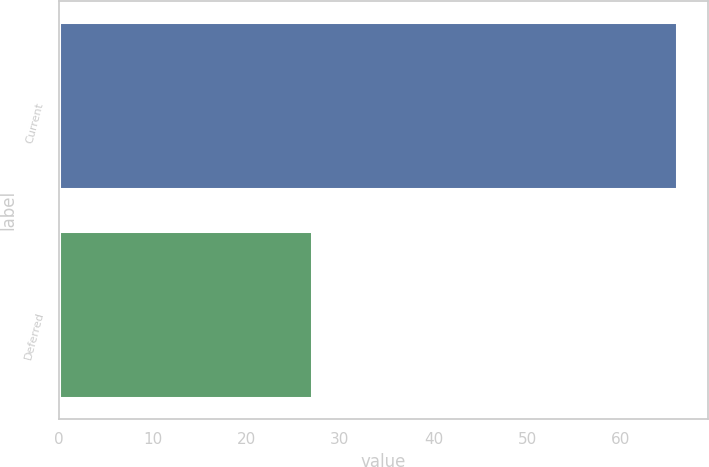Convert chart to OTSL. <chart><loc_0><loc_0><loc_500><loc_500><bar_chart><fcel>Current<fcel>Deferred<nl><fcel>66<fcel>27<nl></chart> 